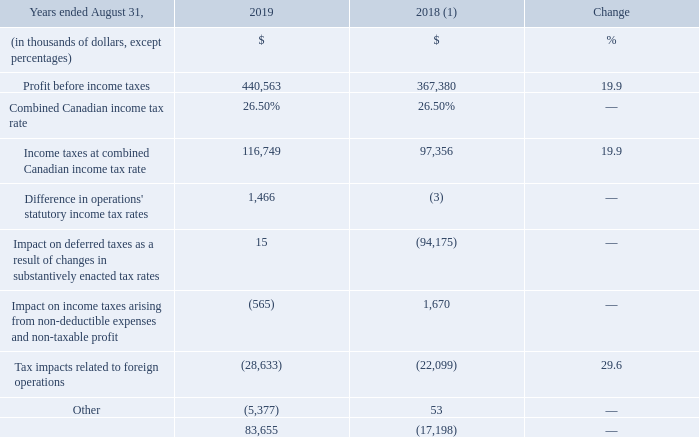3.5 INCOME TAXES
(1) Fiscal 2018 was restated to comply with IFRS 15 and to reflect a change in accounting policy as well as to reclassify results from Cogeco Peer 1 as discontinued operations. For further details, please consult the "Accounting policies" and "Discontinued operations" sections.
Fiscal 2019 income taxes expense amounted to $83.7 million compared to a recovery of $17.2 million for the prior year mainly attributable to: • the effect of the federal rate reduction in the second quarter of fiscal 2018 in the United States; • the increase in profit before income taxes which is mostly related to the impact of the MetroCast acquisition completed in the second quarter of fiscal 2018, and • the appreciation of the US dollar against the Canadian dollar compared to the prior year.
On March 19, 2019, the Department of Finance Canada confirmed the acceleration of tax depreciation on most capital investments for property, plant and equipment acquired after November 20, 2018, which phases out during the period from 2023 to 2028. The federal accelerated tax depreciation had a favorable impact on the current income tax expense of the Corporation in fiscal 2019. On March 21, 2019, the Québec Department of Finance confirmed that it would harmonize with the Federal legislation.
On December 22, 2017, the U.S. federal government enacted the Tax Cuts and Jobs Act (the "Act"). The tax reform reduced the general federal corporate tax rate from 35% to 21% starting after 2017 which reduced net deferred tax liabilities by approximately $94 million (US$74 million) in the second quarter of fiscal 2018. In addition, the Act calls for other changes such as interest deductibility limitations, full deduction of acquisitions of tangible assets, net operating losses limitations as well as base erosion anti-avoidance, which together with tax rate reductions, had an overall favorable impact on the income tax expense.
What were the income tax expense in 2019?
Answer scale should be: million. $83.7. What was the income tax recovery in 2019?
Answer scale should be: million. $17.2. When did  the Department of Finance Canada confirmed the acceleration of tax depreciation on most capital investments for property, plant and equipment acquired after November 20, 2018? March 19, 2019. What was the increase / (decrease) in the Profit before income taxes from 2018 to 2019?
Answer scale should be: thousand. 440,563 - 367,380
Answer: 73183. What was the average Income taxes at combined Canadian income tax rate?
Answer scale should be: thousand. (116,749 + 97,356) / 2
Answer: 107052.5. What was the average Tax impacts related to foreign operations between 2018 and 2019?
Answer scale should be: thousand. - (28,633 + 22,099) / 2
Answer: -25366. 